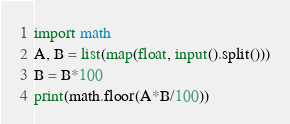Convert code to text. <code><loc_0><loc_0><loc_500><loc_500><_Python_>import math
A, B = list(map(float, input().split()))
B = B*100
print(math.floor(A*B/100))</code> 